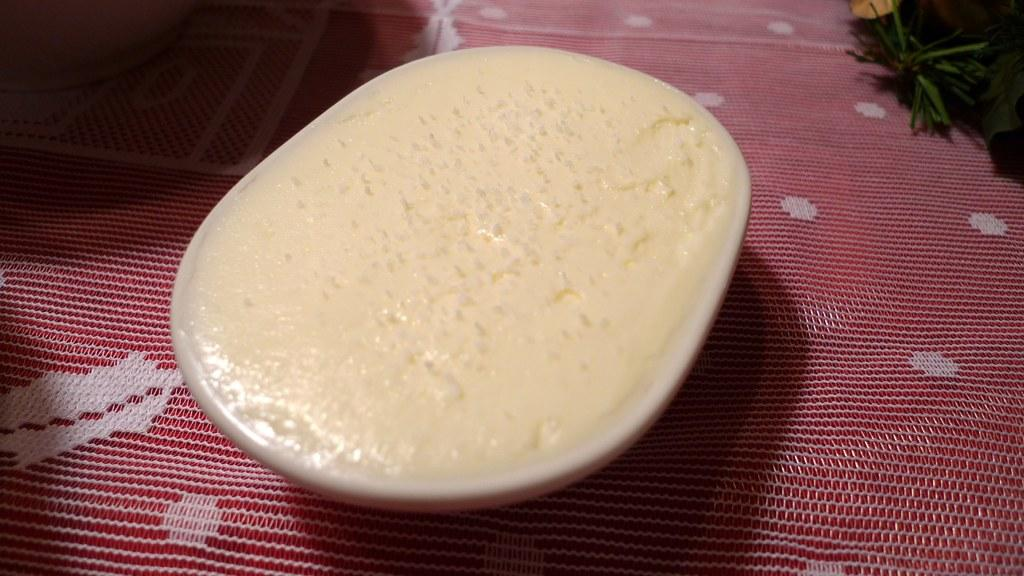What type of dessert is in the image? There is an ice-cream in a cup in the image. Where is the ice-cream cup located? The ice-cream cup is on a bed sheet. Can you describe any other objects or elements in the image? There is a plant visible in the top right corner of the image. What type of paste is being used to clean the spot on the bed sheet in the image? There is no paste or spot visible on the bed sheet in the image. What kind of soap is being used to wash the plant in the image? There is no soap or washing activity involving the plant in the image. 